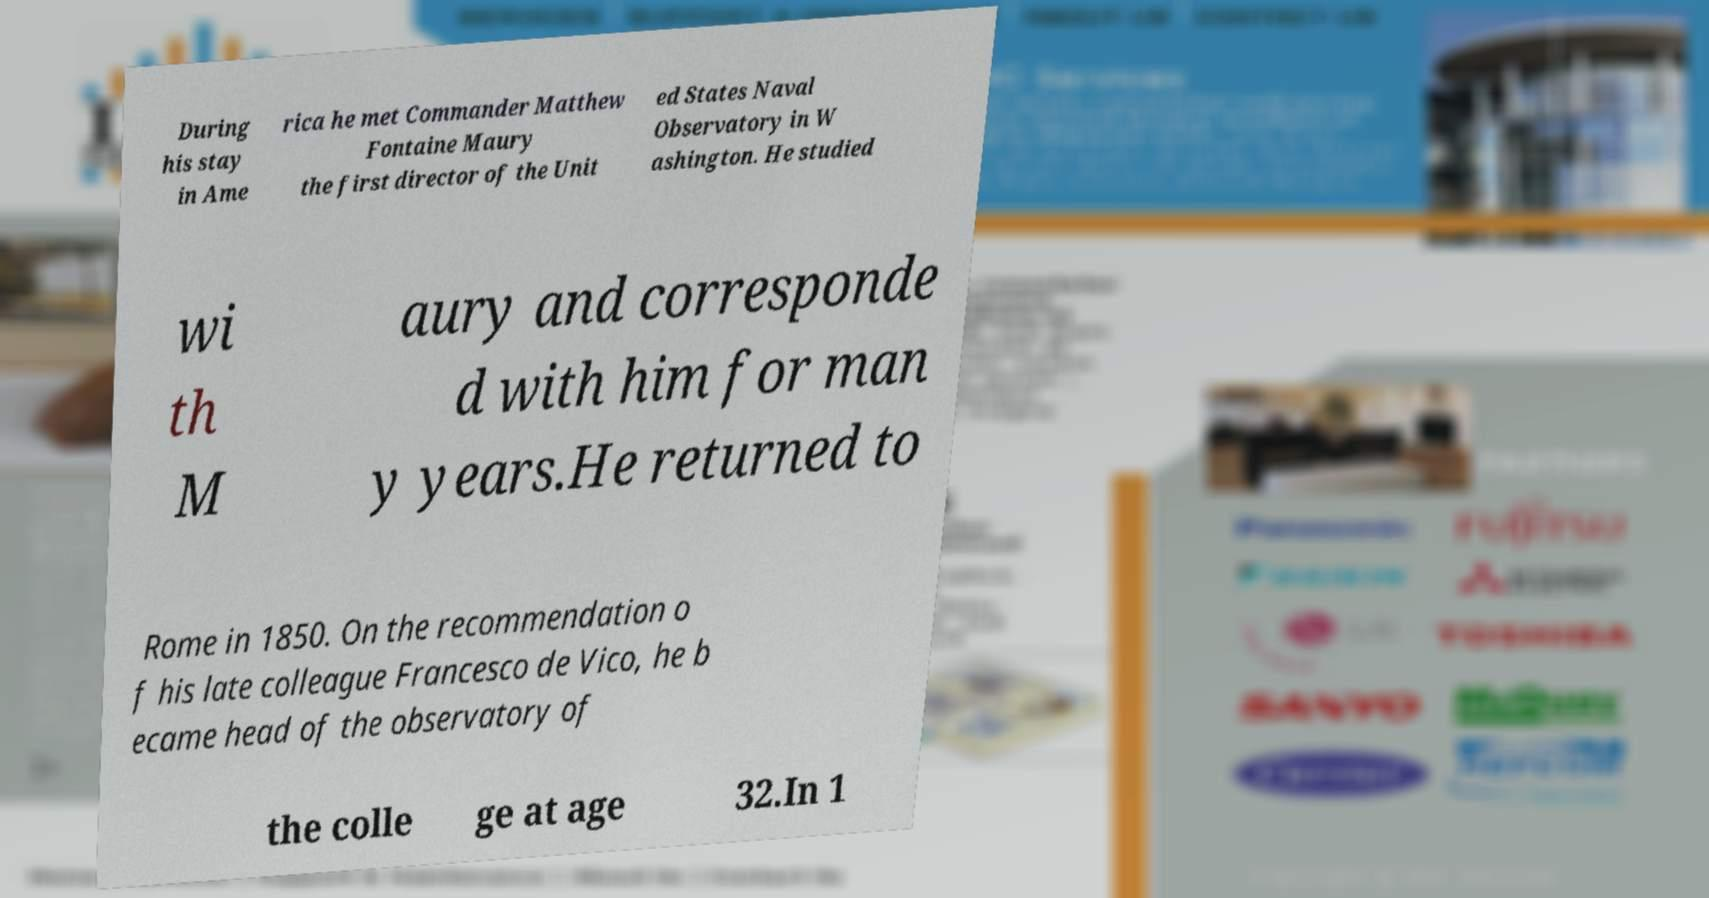Can you read and provide the text displayed in the image?This photo seems to have some interesting text. Can you extract and type it out for me? During his stay in Ame rica he met Commander Matthew Fontaine Maury the first director of the Unit ed States Naval Observatory in W ashington. He studied wi th M aury and corresponde d with him for man y years.He returned to Rome in 1850. On the recommendation o f his late colleague Francesco de Vico, he b ecame head of the observatory of the colle ge at age 32.In 1 